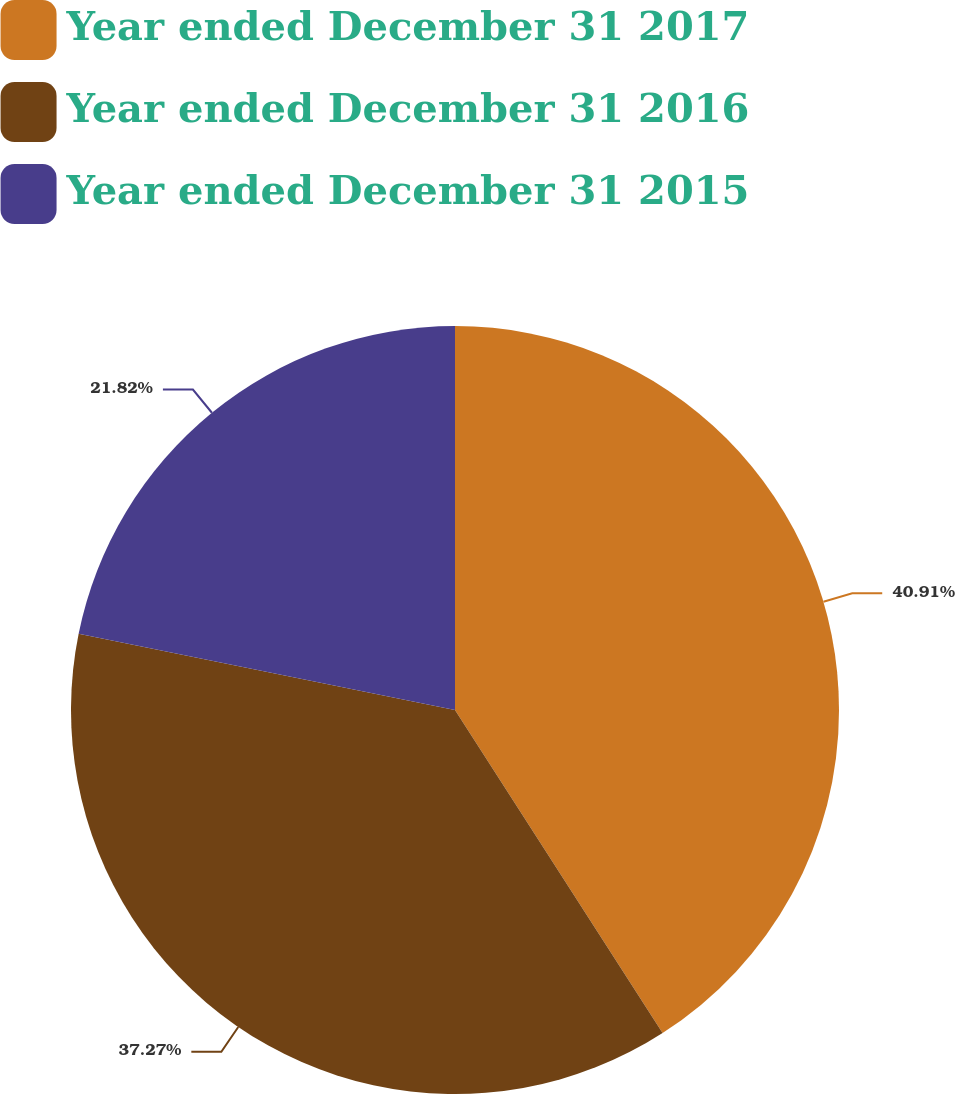Convert chart. <chart><loc_0><loc_0><loc_500><loc_500><pie_chart><fcel>Year ended December 31 2017<fcel>Year ended December 31 2016<fcel>Year ended December 31 2015<nl><fcel>40.91%<fcel>37.27%<fcel>21.82%<nl></chart> 